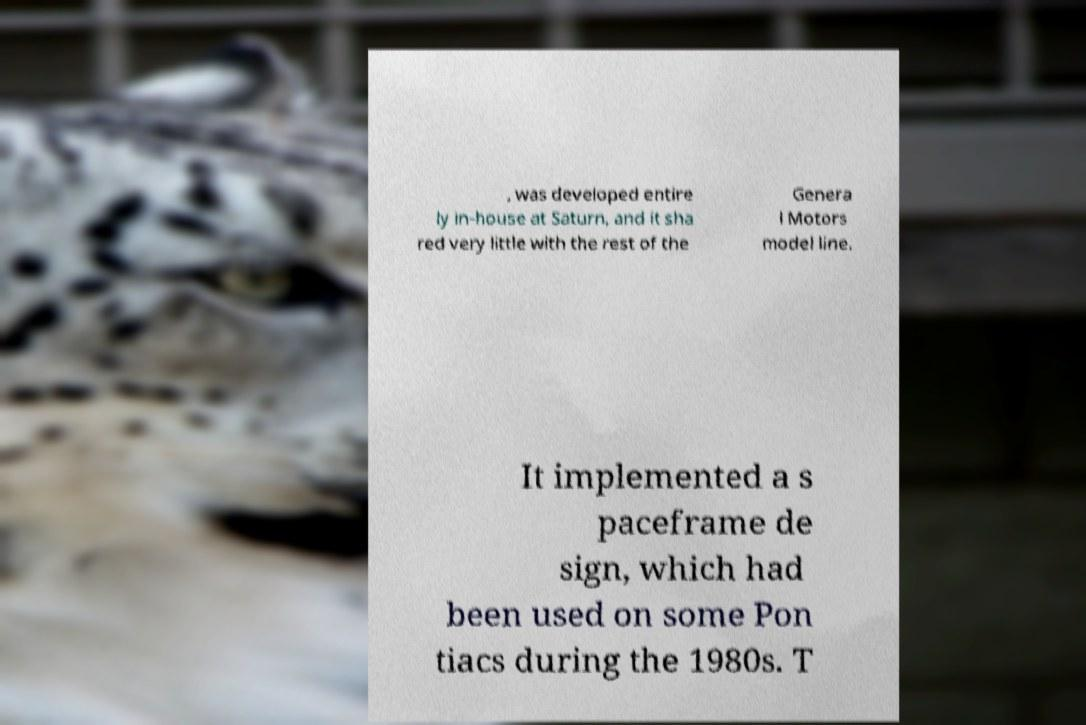I need the written content from this picture converted into text. Can you do that? , was developed entire ly in-house at Saturn, and it sha red very little with the rest of the Genera l Motors model line. It implemented a s paceframe de sign, which had been used on some Pon tiacs during the 1980s. T 